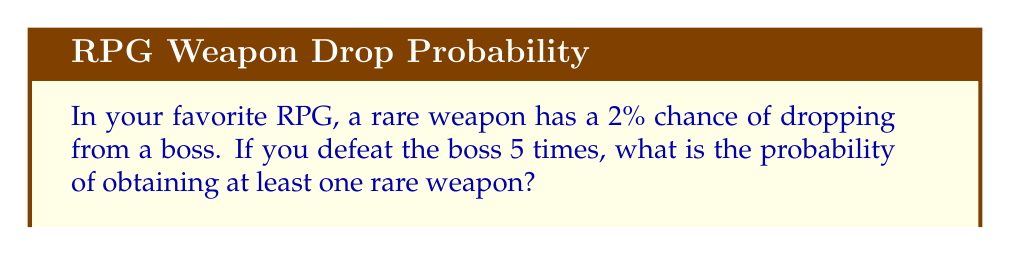Help me with this question. Let's approach this step-by-step:

1) First, let's consider the probability of not getting the rare weapon in a single boss fight:
   $P(\text{no rare weapon}) = 1 - 0.02 = 0.98$

2) For 5 independent boss fights, the probability of not getting any rare weapons is:
   $P(\text{no rare weapons in 5 fights}) = 0.98^5$

3) We can calculate this:
   $0.98^5 \approx 0.9039821$

4) Now, the probability of getting at least one rare weapon is the opposite of getting no rare weapons:
   $P(\text{at least one rare weapon}) = 1 - P(\text{no rare weapons in 5 fights})$

5) Let's calculate:
   $1 - 0.9039821 \approx 0.0960179$

6) Converting to a percentage:
   $0.0960179 \times 100\% \approx 9.60\%$

Therefore, the probability of obtaining at least one rare weapon in 5 boss fights is approximately 9.60%.
Answer: 9.60% 